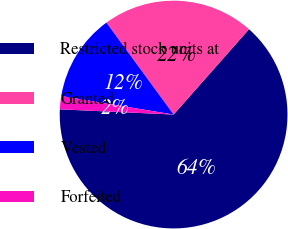Convert chart. <chart><loc_0><loc_0><loc_500><loc_500><pie_chart><fcel>Restricted stock units at<fcel>Granted<fcel>Vested<fcel>Forfeited<nl><fcel>64.21%<fcel>21.56%<fcel>12.35%<fcel>1.87%<nl></chart> 